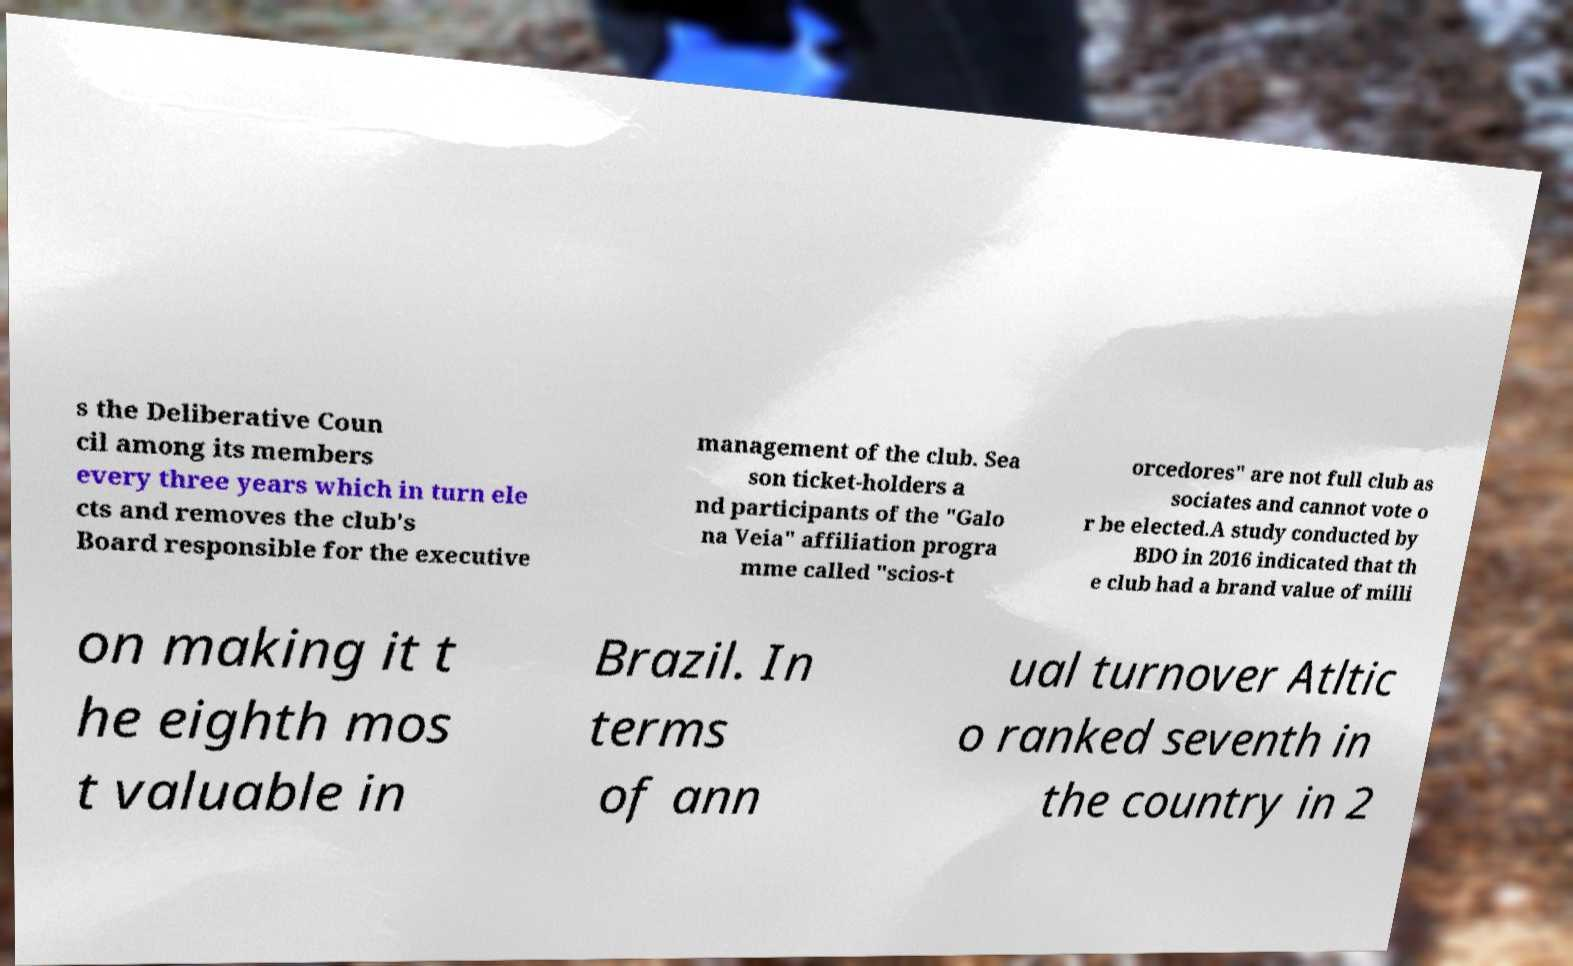For documentation purposes, I need the text within this image transcribed. Could you provide that? s the Deliberative Coun cil among its members every three years which in turn ele cts and removes the club's Board responsible for the executive management of the club. Sea son ticket-holders a nd participants of the "Galo na Veia" affiliation progra mme called "scios-t orcedores" are not full club as sociates and cannot vote o r be elected.A study conducted by BDO in 2016 indicated that th e club had a brand value of milli on making it t he eighth mos t valuable in Brazil. In terms of ann ual turnover Atltic o ranked seventh in the country in 2 